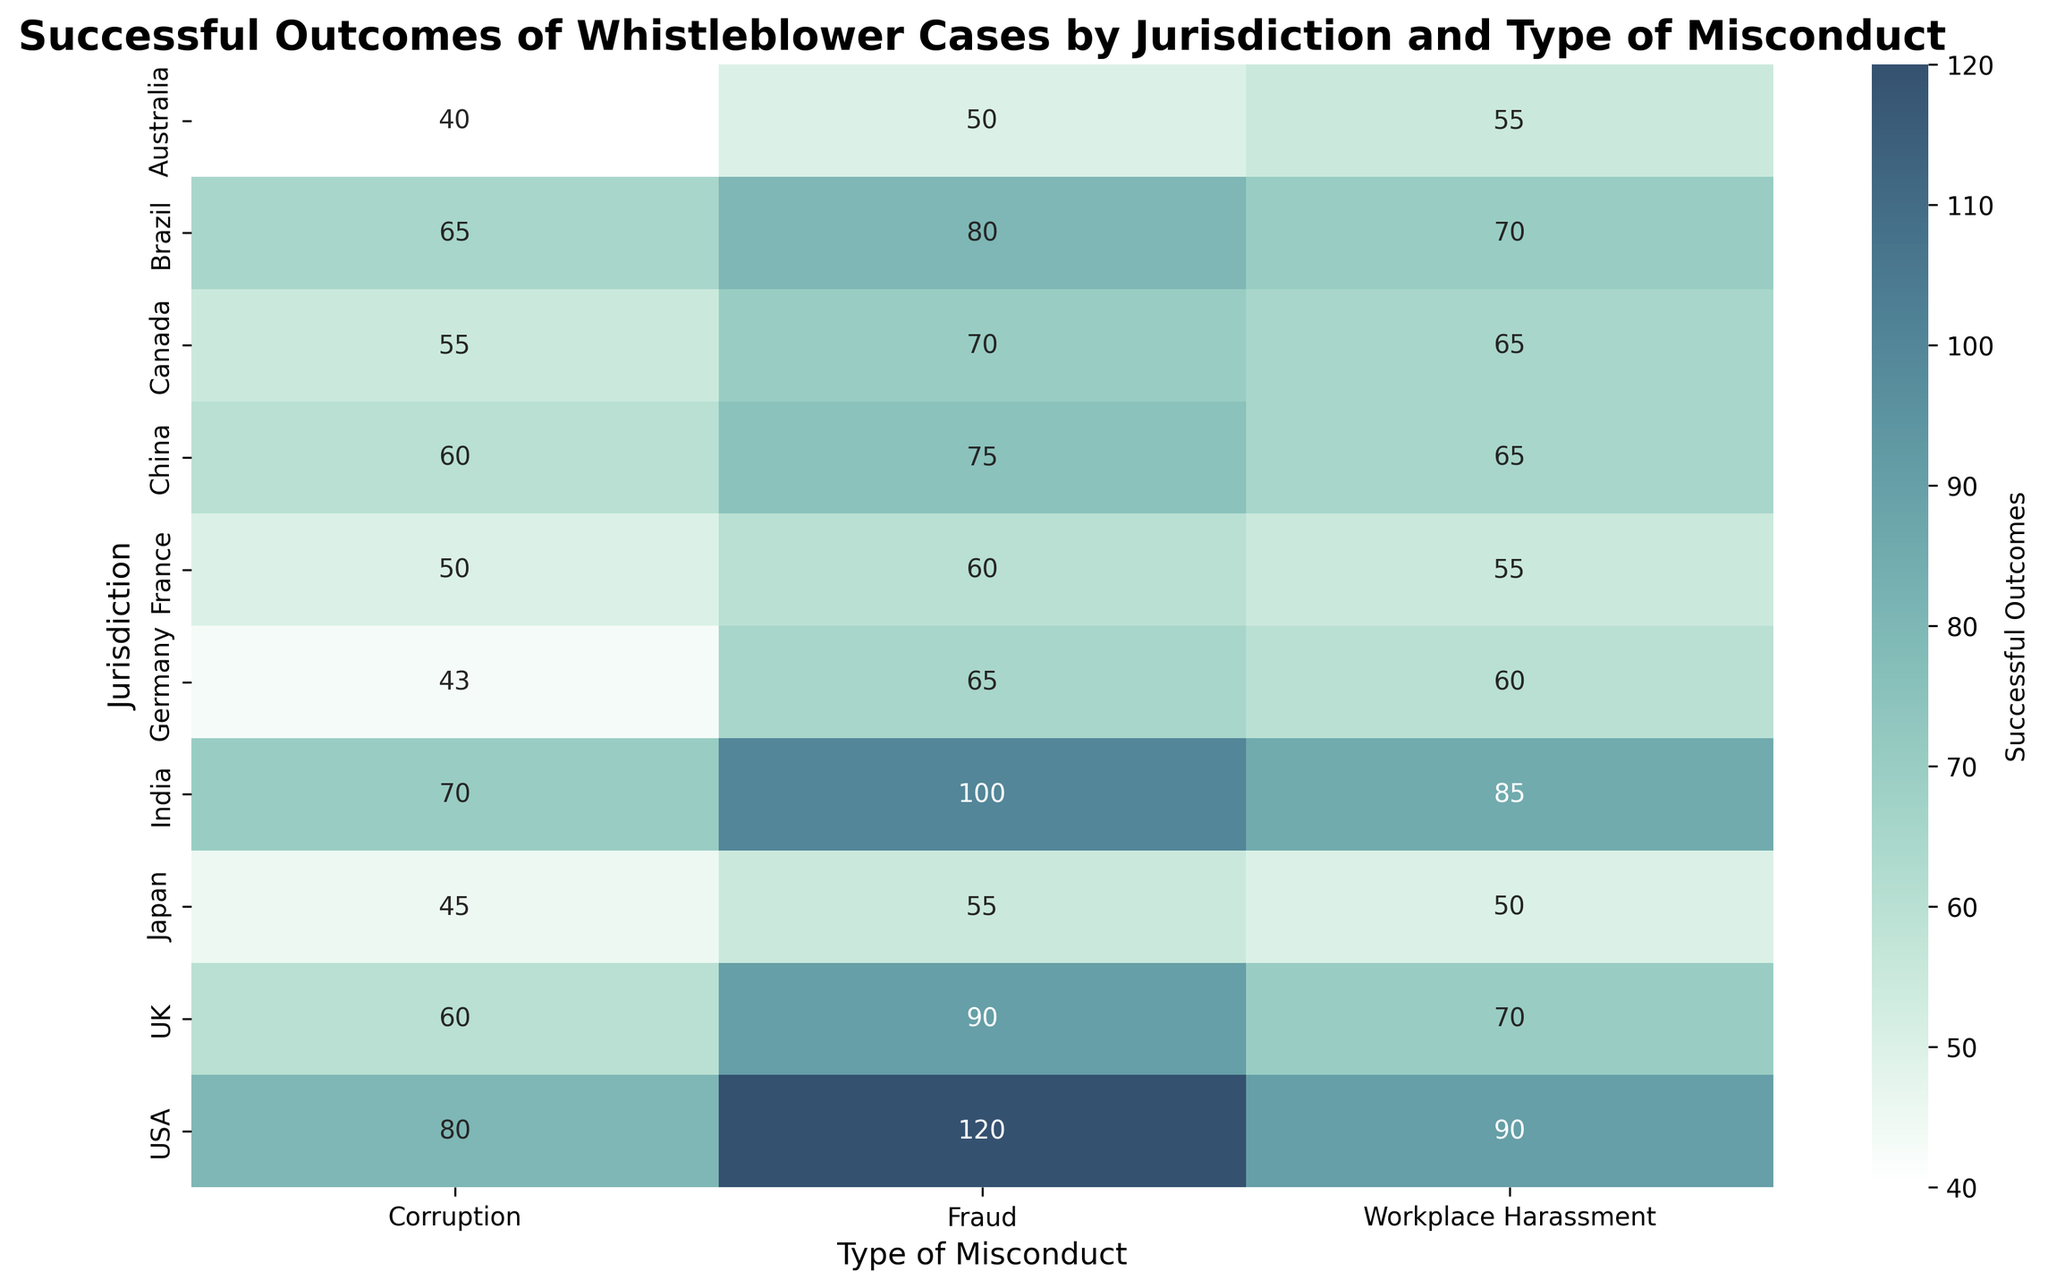Which jurisdiction has the highest successful outcomes for fraud cases? To find out which jurisdiction has the highest successful outcomes for fraud cases, we look at the row labeled "Fraud" in each column representing different jurisdictions in the heatmap. The USA has the highest value of 120.
Answer: USA Which type of misconduct has the lowest number of successful outcomes in Australia? To determine the type of misconduct with the lowest successful outcomes in Australia, look at the column labeled "Australia" and compare the numbers. "Corruption" has the lowest value of 40.
Answer: Corruption What is the sum of successful outcomes for workplace harassment cases in Canada and Germany? Find the values for workplace harassment cases in the Canada and Germany rows, which are 65 and 60 respectively. Sum them up: 65 + 60 = 125.
Answer: 125 How do the successful outcomes for corruption cases in the UK compare to those in India? To compare, look at the values of both jurisdictions for corruption cases. The UK has 60 successful outcomes, while India has 70. India has 10 more successful outcomes than the UK.
Answer: India has more Which jurisdiction has the most evenly balanced heatmap values for all three types of misconduct? To determine this, visually scan the rows for each jurisdiction and compare the relative balance of the values across different misconduct types. Japan's values for fraud (55), corruption (45), and workplace harassment (50) are the most evenly distributed.
Answer: Japan How many more successful outcomes are there for fraud cases in Brazil compared to China? Identify the values for fraud in Brazil (80) and China (75). Subtract the lesser value from the greater value: 80 - 75 = 5.
Answer: 5 What is the total number of successful outcomes for all types of misconduct in France? Sum the numbers for all types of misconduct in France: fraud (60), corruption (50), and workplace harassment (55). The sum is 60 + 50 + 55 = 165.
Answer: 165 Which jurisdiction has the darkest shading for successful outcomes, indicating the highest value? Observe the heatmap colors and identify the darkest shading. The USA has the darkest shading for fraud with a value of 120.
Answer: USA Is the distribution of successful outcomes for workplace harassment cases more spread out or concentrated in Brazil compared to other jurisdictions? To compare, look at the distribution of values for workplace harassment cases across all jurisdictions. Brazil has 70 successful outcomes, and compared to the spread in other jurisdictions, this is on the higher side but not an outlier. The distribution is relatively balanced across jurisdictions.
Answer: Concentrated In which jurisdiction do corruption cases have the closest number of successful outcomes compared to fraud cases? Compare the values for corruption and fraud in each jurisdiction. In Canada, the values are closest with 55 for corruption and 70 for fraud, a difference of 15.
Answer: Canada 